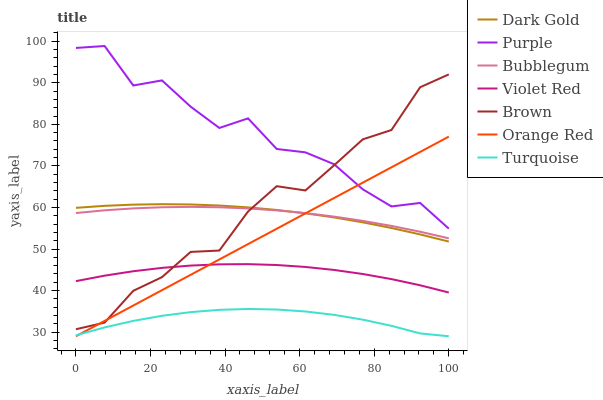Does Violet Red have the minimum area under the curve?
Answer yes or no. No. Does Violet Red have the maximum area under the curve?
Answer yes or no. No. Is Violet Red the smoothest?
Answer yes or no. No. Is Violet Red the roughest?
Answer yes or no. No. Does Violet Red have the lowest value?
Answer yes or no. No. Does Violet Red have the highest value?
Answer yes or no. No. Is Bubblegum less than Purple?
Answer yes or no. Yes. Is Purple greater than Dark Gold?
Answer yes or no. Yes. Does Bubblegum intersect Purple?
Answer yes or no. No. 